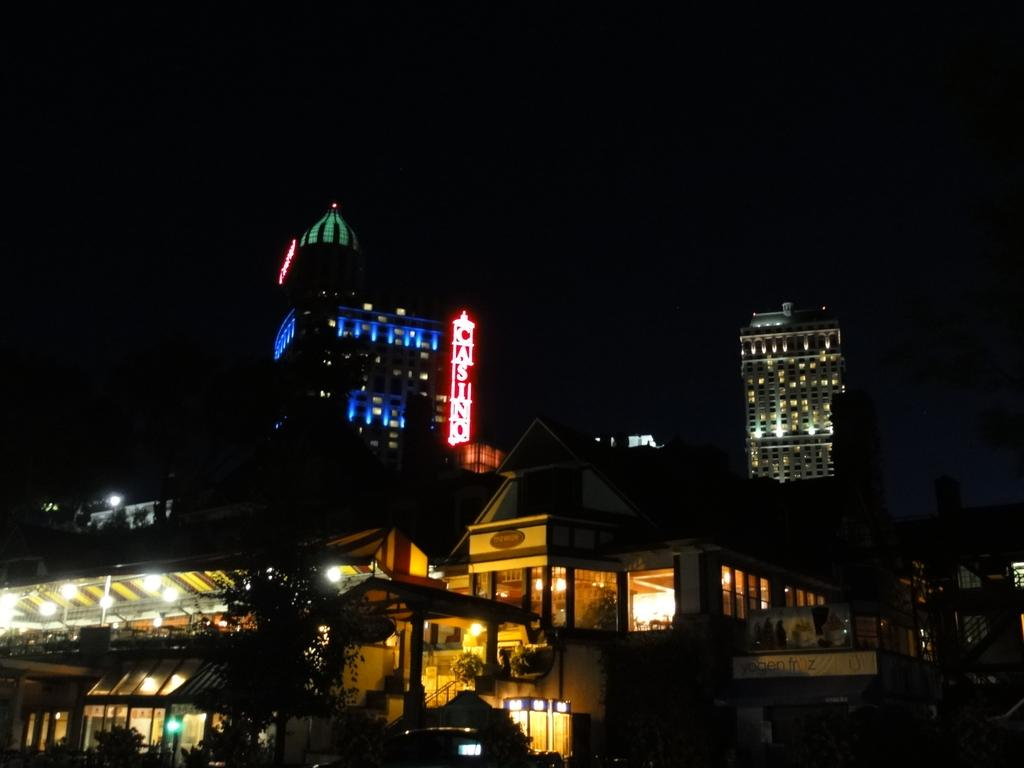What type of structures can be seen in the image? There are buildings in the image. What type of vegetation is present in the image? There are trees and plants in the image. What type of illumination is visible in the image? There are lights in the image. How would you describe the overall lighting in the image? The background of the image is dark. How many oranges are being carried by the laborer in the image? There is no laborer or oranges present in the image. What type of luggage is the porter carrying in the image? There is no porter or luggage present in the image. 